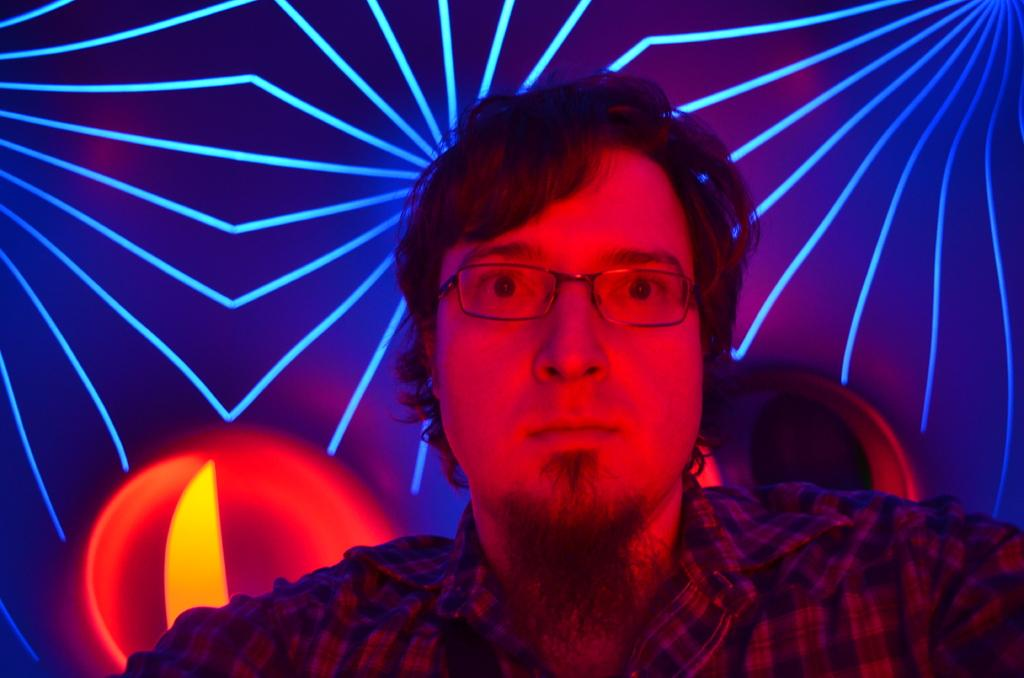What is the main subject of the image? There is a person in the image. What can be seen on the wall behind the person? Disco lights are present on the wall behind the person. What is the purpose of the spade in the image? There is no spade present in the image. What type of test is being conducted in the image? There is no test being conducted in the image. 